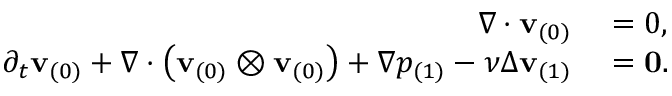Convert formula to latex. <formula><loc_0><loc_0><loc_500><loc_500>\begin{array} { r l } { \nabla \cdot v _ { ( 0 ) } } & = 0 , } \\ { \partial _ { t } v _ { ( 0 ) } + \nabla \cdot \left ( v _ { ( 0 ) } \otimes v _ { ( 0 ) } \right ) + \nabla p _ { ( 1 ) } - \nu \Delta v _ { ( 1 ) } } & = 0 . } \end{array}</formula> 